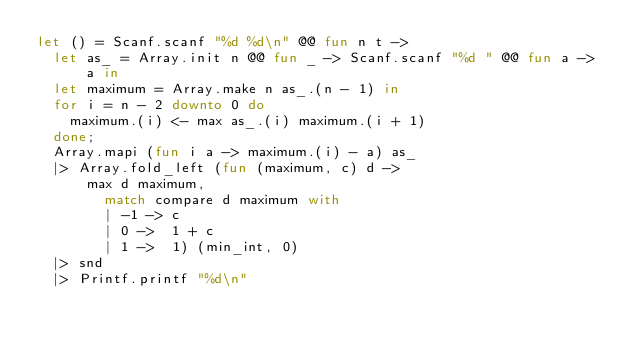<code> <loc_0><loc_0><loc_500><loc_500><_OCaml_>let () = Scanf.scanf "%d %d\n" @@ fun n t ->
  let as_ = Array.init n @@ fun _ -> Scanf.scanf "%d " @@ fun a -> a in
  let maximum = Array.make n as_.(n - 1) in
  for i = n - 2 downto 0 do
    maximum.(i) <- max as_.(i) maximum.(i + 1)
  done;
  Array.mapi (fun i a -> maximum.(i) - a) as_
  |> Array.fold_left (fun (maximum, c) d ->
      max d maximum,
        match compare d maximum with
        | -1 -> c
        | 0 ->  1 + c
        | 1 ->  1) (min_int, 0)
  |> snd
  |> Printf.printf "%d\n"</code> 